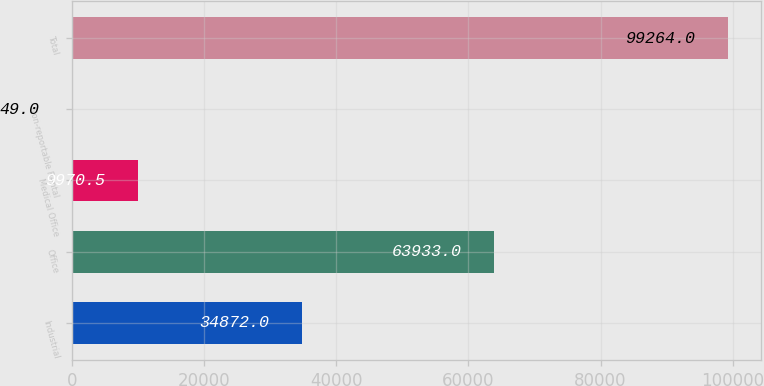Convert chart to OTSL. <chart><loc_0><loc_0><loc_500><loc_500><bar_chart><fcel>Industrial<fcel>Office<fcel>Medical Office<fcel>Non-reportable Rental<fcel>Total<nl><fcel>34872<fcel>63933<fcel>9970.5<fcel>49<fcel>99264<nl></chart> 